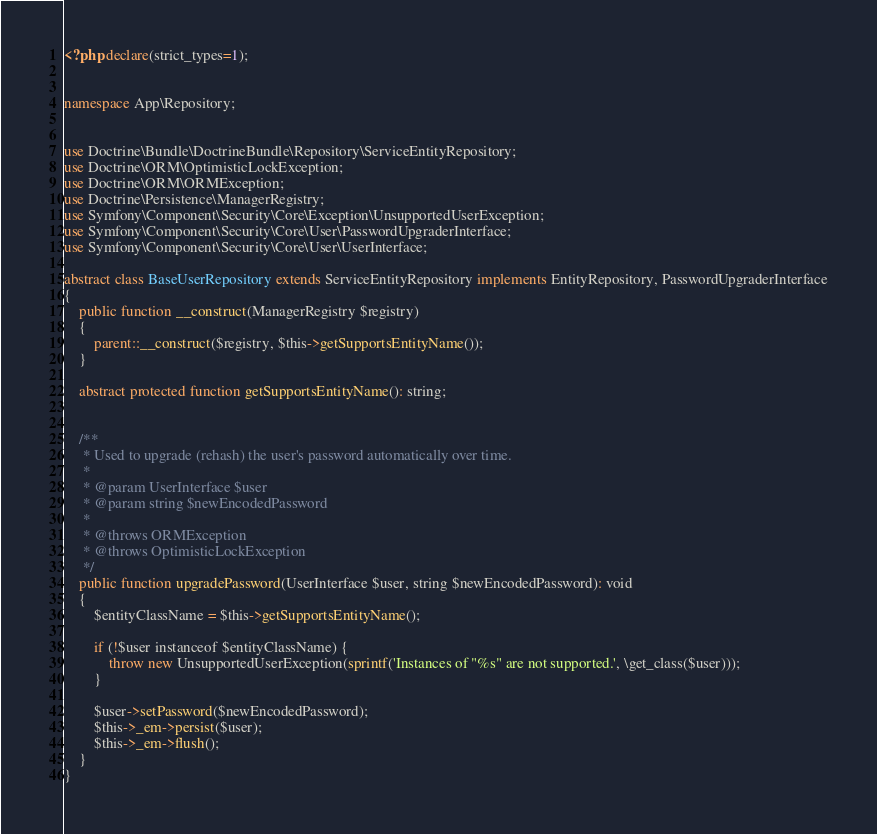Convert code to text. <code><loc_0><loc_0><loc_500><loc_500><_PHP_><?php declare(strict_types=1);


namespace App\Repository;


use Doctrine\Bundle\DoctrineBundle\Repository\ServiceEntityRepository;
use Doctrine\ORM\OptimisticLockException;
use Doctrine\ORM\ORMException;
use Doctrine\Persistence\ManagerRegistry;
use Symfony\Component\Security\Core\Exception\UnsupportedUserException;
use Symfony\Component\Security\Core\User\PasswordUpgraderInterface;
use Symfony\Component\Security\Core\User\UserInterface;

abstract class BaseUserRepository extends ServiceEntityRepository implements EntityRepository, PasswordUpgraderInterface
{
    public function __construct(ManagerRegistry $registry)
    {
        parent::__construct($registry, $this->getSupportsEntityName());
    }

    abstract protected function getSupportsEntityName(): string;


    /**
     * Used to upgrade (rehash) the user's password automatically over time.
     *
     * @param UserInterface $user
     * @param string $newEncodedPassword
     *
     * @throws ORMException
     * @throws OptimisticLockException
     */
    public function upgradePassword(UserInterface $user, string $newEncodedPassword): void
    {
        $entityClassName = $this->getSupportsEntityName();

        if (!$user instanceof $entityClassName) {
            throw new UnsupportedUserException(sprintf('Instances of "%s" are not supported.', \get_class($user)));
        }

        $user->setPassword($newEncodedPassword);
        $this->_em->persist($user);
        $this->_em->flush();
    }
}
</code> 